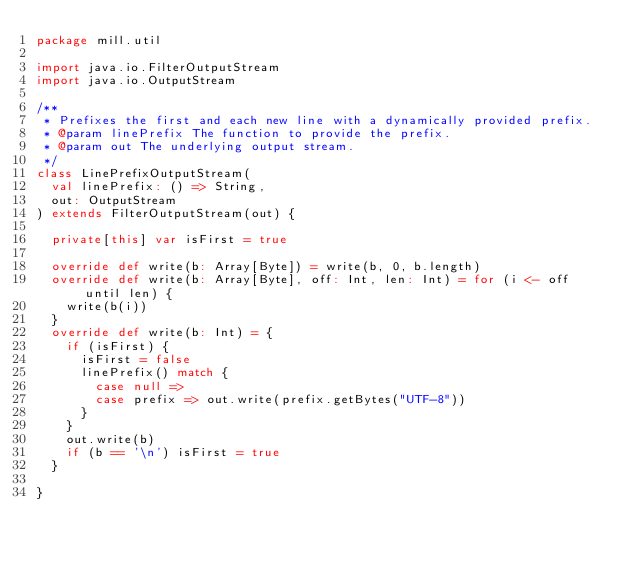Convert code to text. <code><loc_0><loc_0><loc_500><loc_500><_Scala_>package mill.util

import java.io.FilterOutputStream
import java.io.OutputStream

/**
 * Prefixes the first and each new line with a dynamically provided prefix.
 * @param linePrefix The function to provide the prefix.
 * @param out The underlying output stream.
 */
class LinePrefixOutputStream(
  val linePrefix: () => String,
  out: OutputStream
) extends FilterOutputStream(out) {

  private[this] var isFirst = true

  override def write(b: Array[Byte]) = write(b, 0, b.length)
  override def write(b: Array[Byte], off: Int, len: Int) = for (i <- off until len) {
    write(b(i))
  }
  override def write(b: Int) = {
    if (isFirst) {
      isFirst = false
      linePrefix() match {
        case null =>
        case prefix => out.write(prefix.getBytes("UTF-8"))
      }
    }
    out.write(b)
    if (b == '\n') isFirst = true
  }

}
</code> 